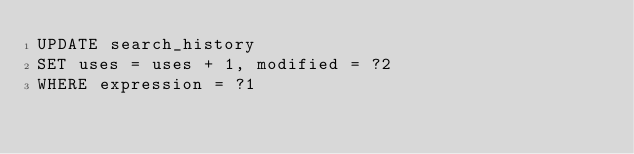Convert code to text. <code><loc_0><loc_0><loc_500><loc_500><_SQL_>UPDATE search_history
SET uses = uses + 1, modified = ?2
WHERE expression = ?1

</code> 